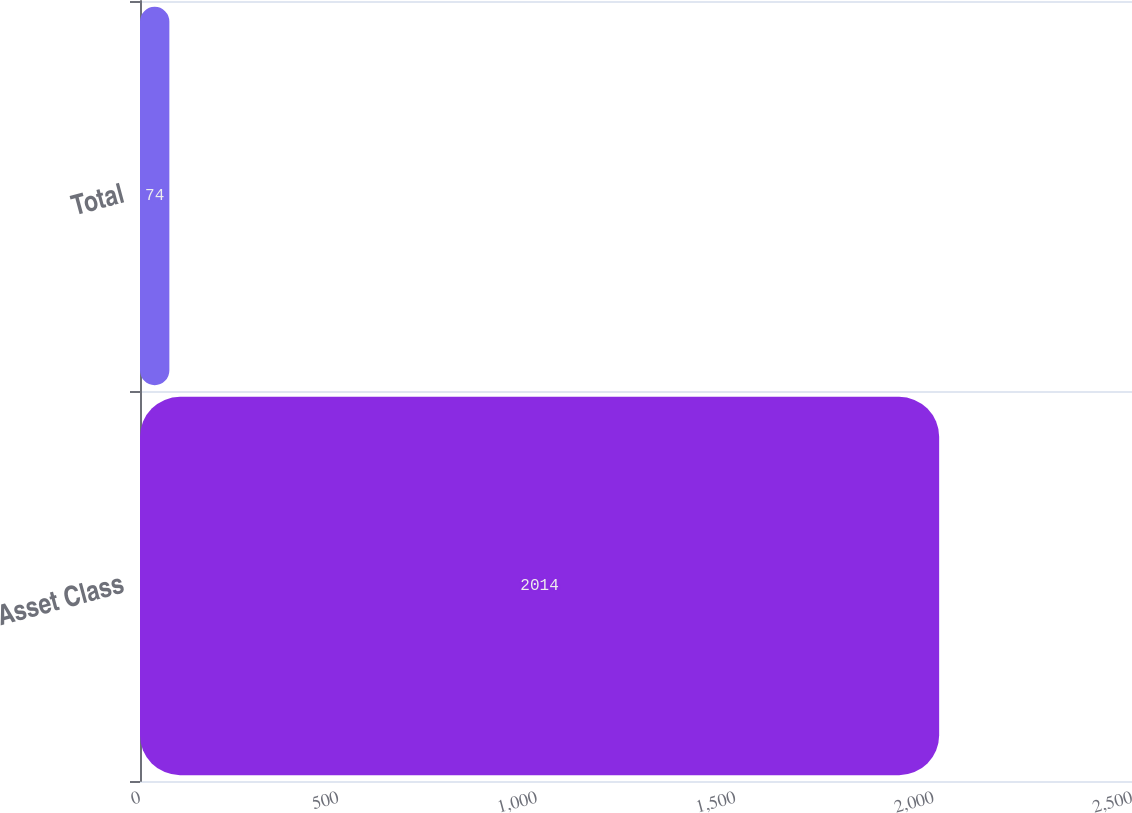<chart> <loc_0><loc_0><loc_500><loc_500><bar_chart><fcel>Asset Class<fcel>Total<nl><fcel>2014<fcel>74<nl></chart> 